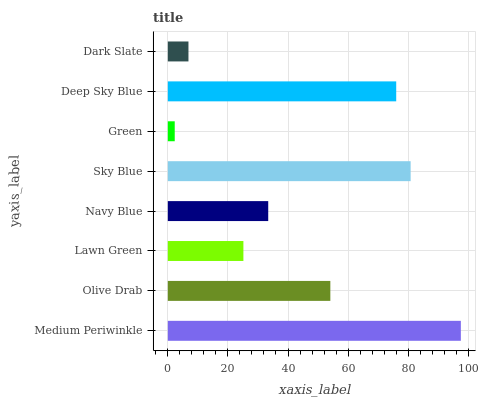Is Green the minimum?
Answer yes or no. Yes. Is Medium Periwinkle the maximum?
Answer yes or no. Yes. Is Olive Drab the minimum?
Answer yes or no. No. Is Olive Drab the maximum?
Answer yes or no. No. Is Medium Periwinkle greater than Olive Drab?
Answer yes or no. Yes. Is Olive Drab less than Medium Periwinkle?
Answer yes or no. Yes. Is Olive Drab greater than Medium Periwinkle?
Answer yes or no. No. Is Medium Periwinkle less than Olive Drab?
Answer yes or no. No. Is Olive Drab the high median?
Answer yes or no. Yes. Is Navy Blue the low median?
Answer yes or no. Yes. Is Lawn Green the high median?
Answer yes or no. No. Is Dark Slate the low median?
Answer yes or no. No. 